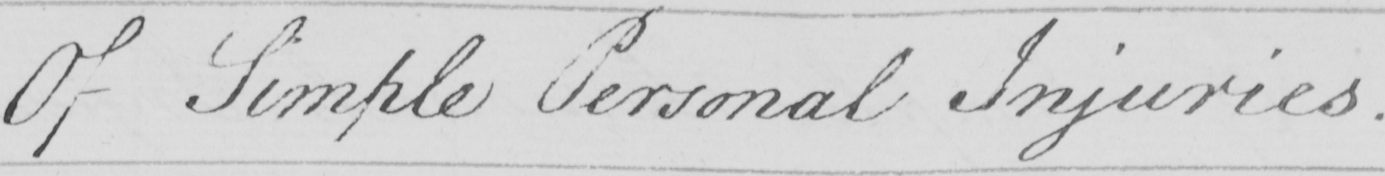What does this handwritten line say? Of Simple Personal Injuries . 